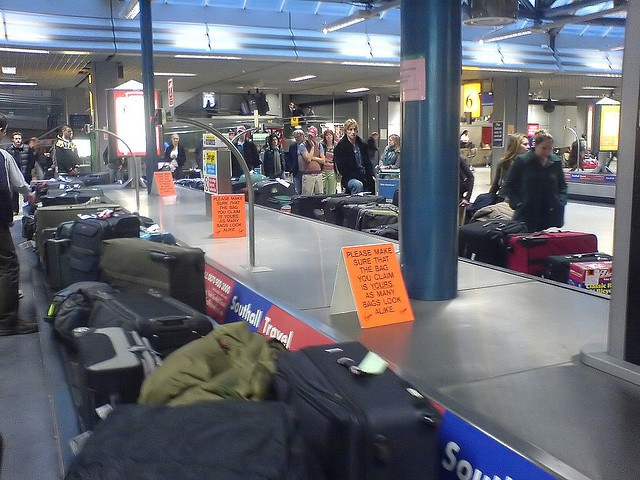Describe the objects in this image and their specific colors. I can see suitcase in gray and black tones, suitcase in gray and black tones, suitcase in gray and black tones, suitcase in gray and black tones, and suitcase in gray, black, and darkgray tones in this image. 